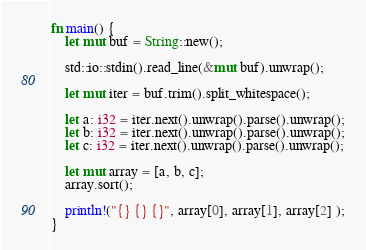<code> <loc_0><loc_0><loc_500><loc_500><_Rust_>fn main() {
    let mut buf = String::new();

    std::io::stdin().read_line(&mut buf).unwrap();

    let mut iter = buf.trim().split_whitespace();

    let a: i32 = iter.next().unwrap().parse().unwrap();
    let b: i32 = iter.next().unwrap().parse().unwrap();
    let c: i32 = iter.next().unwrap().parse().unwrap();

    let mut array = [a, b, c];
    array.sort();

    println!("{} {} {}", array[0], array[1], array[2] );
}
</code> 